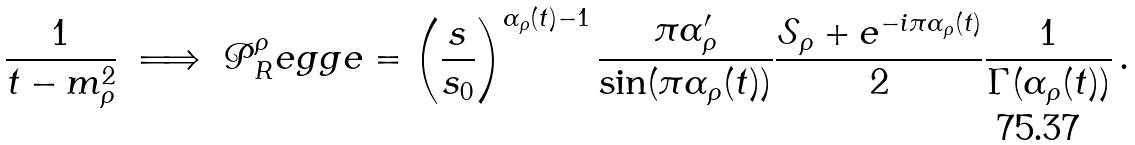<formula> <loc_0><loc_0><loc_500><loc_500>\frac { 1 } { t - m _ { \rho } ^ { 2 } } \ \Longrightarrow \ \mathcal { P } ^ { \rho } _ { R } e g g e = \left ( \frac { s } { s _ { 0 } } \right ) ^ { \alpha _ { \rho } ( t ) - 1 } \frac { \pi \alpha ^ { \prime } _ { \rho } } { \sin ( \pi \alpha _ { \rho } ( t ) ) } \frac { \mathcal { S } _ { \rho } + e ^ { - i \pi \alpha _ { \rho } ( t ) } } { 2 } \frac { 1 } { \Gamma ( \alpha _ { \rho } ( t ) ) } \, .</formula> 